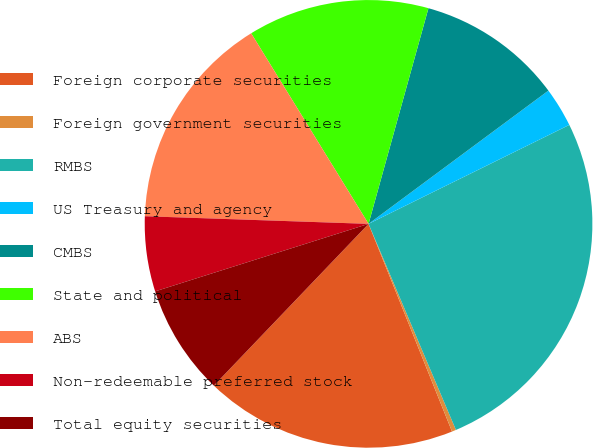Convert chart. <chart><loc_0><loc_0><loc_500><loc_500><pie_chart><fcel>Foreign corporate securities<fcel>Foreign government securities<fcel>RMBS<fcel>US Treasury and agency<fcel>CMBS<fcel>State and political<fcel>ABS<fcel>Non-redeemable preferred stock<fcel>Total equity securities<nl><fcel>18.23%<fcel>0.3%<fcel>25.91%<fcel>2.86%<fcel>10.54%<fcel>13.1%<fcel>15.67%<fcel>5.42%<fcel>7.98%<nl></chart> 